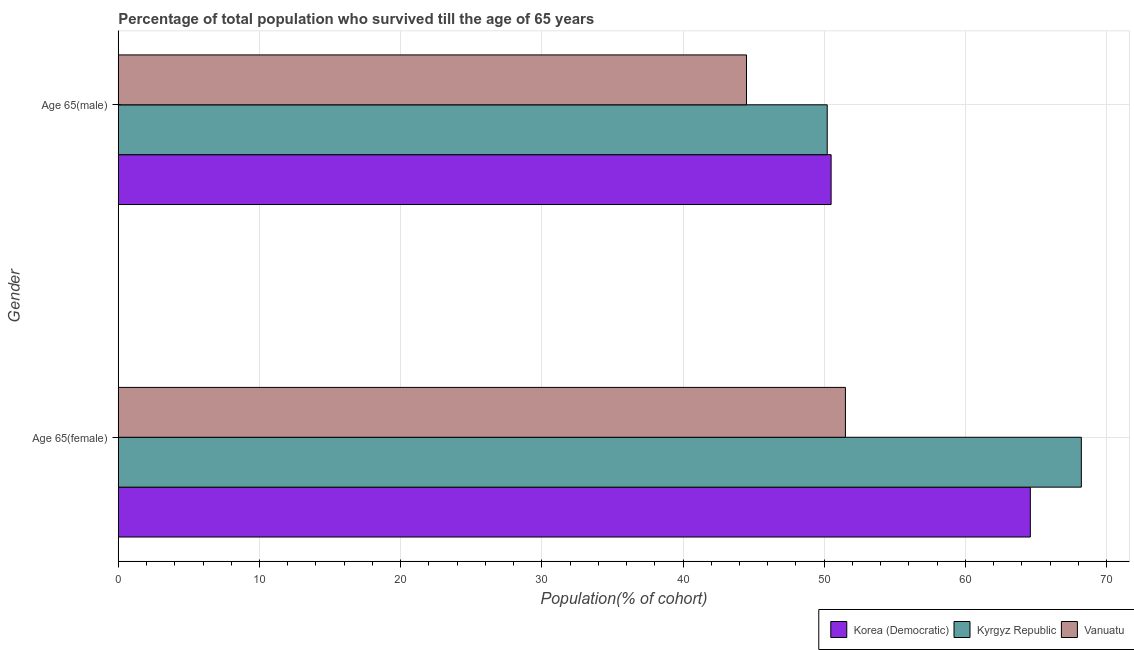Are the number of bars on each tick of the Y-axis equal?
Give a very brief answer. Yes. How many bars are there on the 2nd tick from the top?
Give a very brief answer. 3. What is the label of the 1st group of bars from the top?
Provide a succinct answer. Age 65(male). What is the percentage of female population who survived till age of 65 in Vanuatu?
Ensure brevity in your answer.  51.5. Across all countries, what is the maximum percentage of female population who survived till age of 65?
Your response must be concise. 68.21. Across all countries, what is the minimum percentage of male population who survived till age of 65?
Ensure brevity in your answer.  44.5. In which country was the percentage of female population who survived till age of 65 maximum?
Offer a terse response. Kyrgyz Republic. In which country was the percentage of male population who survived till age of 65 minimum?
Your answer should be compact. Vanuatu. What is the total percentage of male population who survived till age of 65 in the graph?
Your response must be concise. 145.2. What is the difference between the percentage of female population who survived till age of 65 in Kyrgyz Republic and that in Vanuatu?
Your answer should be compact. 16.71. What is the difference between the percentage of female population who survived till age of 65 in Kyrgyz Republic and the percentage of male population who survived till age of 65 in Vanuatu?
Your response must be concise. 23.72. What is the average percentage of female population who survived till age of 65 per country?
Your answer should be compact. 61.44. What is the difference between the percentage of female population who survived till age of 65 and percentage of male population who survived till age of 65 in Korea (Democratic)?
Provide a short and direct response. 14.11. In how many countries, is the percentage of male population who survived till age of 65 greater than 16 %?
Offer a very short reply. 3. What is the ratio of the percentage of male population who survived till age of 65 in Vanuatu to that in Korea (Democratic)?
Offer a very short reply. 0.88. What does the 3rd bar from the top in Age 65(male) represents?
Your answer should be compact. Korea (Democratic). What does the 3rd bar from the bottom in Age 65(female) represents?
Your response must be concise. Vanuatu. How many bars are there?
Give a very brief answer. 6. Does the graph contain any zero values?
Make the answer very short. No. Does the graph contain grids?
Make the answer very short. Yes. Where does the legend appear in the graph?
Your answer should be very brief. Bottom right. How many legend labels are there?
Your answer should be very brief. 3. What is the title of the graph?
Offer a terse response. Percentage of total population who survived till the age of 65 years. Does "Sudan" appear as one of the legend labels in the graph?
Your answer should be very brief. No. What is the label or title of the X-axis?
Offer a terse response. Population(% of cohort). What is the Population(% of cohort) in Korea (Democratic) in Age 65(female)?
Give a very brief answer. 64.6. What is the Population(% of cohort) of Kyrgyz Republic in Age 65(female)?
Provide a short and direct response. 68.21. What is the Population(% of cohort) in Vanuatu in Age 65(female)?
Give a very brief answer. 51.5. What is the Population(% of cohort) of Korea (Democratic) in Age 65(male)?
Make the answer very short. 50.49. What is the Population(% of cohort) in Kyrgyz Republic in Age 65(male)?
Make the answer very short. 50.21. What is the Population(% of cohort) in Vanuatu in Age 65(male)?
Provide a short and direct response. 44.5. Across all Gender, what is the maximum Population(% of cohort) in Korea (Democratic)?
Offer a terse response. 64.6. Across all Gender, what is the maximum Population(% of cohort) in Kyrgyz Republic?
Offer a terse response. 68.21. Across all Gender, what is the maximum Population(% of cohort) in Vanuatu?
Offer a terse response. 51.5. Across all Gender, what is the minimum Population(% of cohort) of Korea (Democratic)?
Offer a very short reply. 50.49. Across all Gender, what is the minimum Population(% of cohort) of Kyrgyz Republic?
Provide a short and direct response. 50.21. Across all Gender, what is the minimum Population(% of cohort) of Vanuatu?
Make the answer very short. 44.5. What is the total Population(% of cohort) in Korea (Democratic) in the graph?
Your answer should be very brief. 115.09. What is the total Population(% of cohort) in Kyrgyz Republic in the graph?
Make the answer very short. 118.43. What is the total Population(% of cohort) in Vanuatu in the graph?
Provide a succinct answer. 96. What is the difference between the Population(% of cohort) of Korea (Democratic) in Age 65(female) and that in Age 65(male)?
Your response must be concise. 14.11. What is the difference between the Population(% of cohort) of Kyrgyz Republic in Age 65(female) and that in Age 65(male)?
Provide a short and direct response. 18. What is the difference between the Population(% of cohort) of Vanuatu in Age 65(female) and that in Age 65(male)?
Keep it short and to the point. 7.01. What is the difference between the Population(% of cohort) in Korea (Democratic) in Age 65(female) and the Population(% of cohort) in Kyrgyz Republic in Age 65(male)?
Keep it short and to the point. 14.39. What is the difference between the Population(% of cohort) of Korea (Democratic) in Age 65(female) and the Population(% of cohort) of Vanuatu in Age 65(male)?
Your answer should be very brief. 20.11. What is the difference between the Population(% of cohort) in Kyrgyz Republic in Age 65(female) and the Population(% of cohort) in Vanuatu in Age 65(male)?
Ensure brevity in your answer.  23.72. What is the average Population(% of cohort) of Korea (Democratic) per Gender?
Your answer should be compact. 57.55. What is the average Population(% of cohort) in Kyrgyz Republic per Gender?
Provide a short and direct response. 59.21. What is the average Population(% of cohort) of Vanuatu per Gender?
Give a very brief answer. 48. What is the difference between the Population(% of cohort) in Korea (Democratic) and Population(% of cohort) in Kyrgyz Republic in Age 65(female)?
Provide a short and direct response. -3.61. What is the difference between the Population(% of cohort) in Korea (Democratic) and Population(% of cohort) in Vanuatu in Age 65(female)?
Offer a very short reply. 13.1. What is the difference between the Population(% of cohort) in Kyrgyz Republic and Population(% of cohort) in Vanuatu in Age 65(female)?
Provide a short and direct response. 16.71. What is the difference between the Population(% of cohort) of Korea (Democratic) and Population(% of cohort) of Kyrgyz Republic in Age 65(male)?
Give a very brief answer. 0.28. What is the difference between the Population(% of cohort) of Korea (Democratic) and Population(% of cohort) of Vanuatu in Age 65(male)?
Ensure brevity in your answer.  5.99. What is the difference between the Population(% of cohort) in Kyrgyz Republic and Population(% of cohort) in Vanuatu in Age 65(male)?
Offer a very short reply. 5.72. What is the ratio of the Population(% of cohort) in Korea (Democratic) in Age 65(female) to that in Age 65(male)?
Make the answer very short. 1.28. What is the ratio of the Population(% of cohort) in Kyrgyz Republic in Age 65(female) to that in Age 65(male)?
Your answer should be very brief. 1.36. What is the ratio of the Population(% of cohort) of Vanuatu in Age 65(female) to that in Age 65(male)?
Provide a succinct answer. 1.16. What is the difference between the highest and the second highest Population(% of cohort) of Korea (Democratic)?
Provide a short and direct response. 14.11. What is the difference between the highest and the second highest Population(% of cohort) of Kyrgyz Republic?
Make the answer very short. 18. What is the difference between the highest and the second highest Population(% of cohort) in Vanuatu?
Give a very brief answer. 7.01. What is the difference between the highest and the lowest Population(% of cohort) in Korea (Democratic)?
Your response must be concise. 14.11. What is the difference between the highest and the lowest Population(% of cohort) in Kyrgyz Republic?
Provide a short and direct response. 18. What is the difference between the highest and the lowest Population(% of cohort) of Vanuatu?
Make the answer very short. 7.01. 